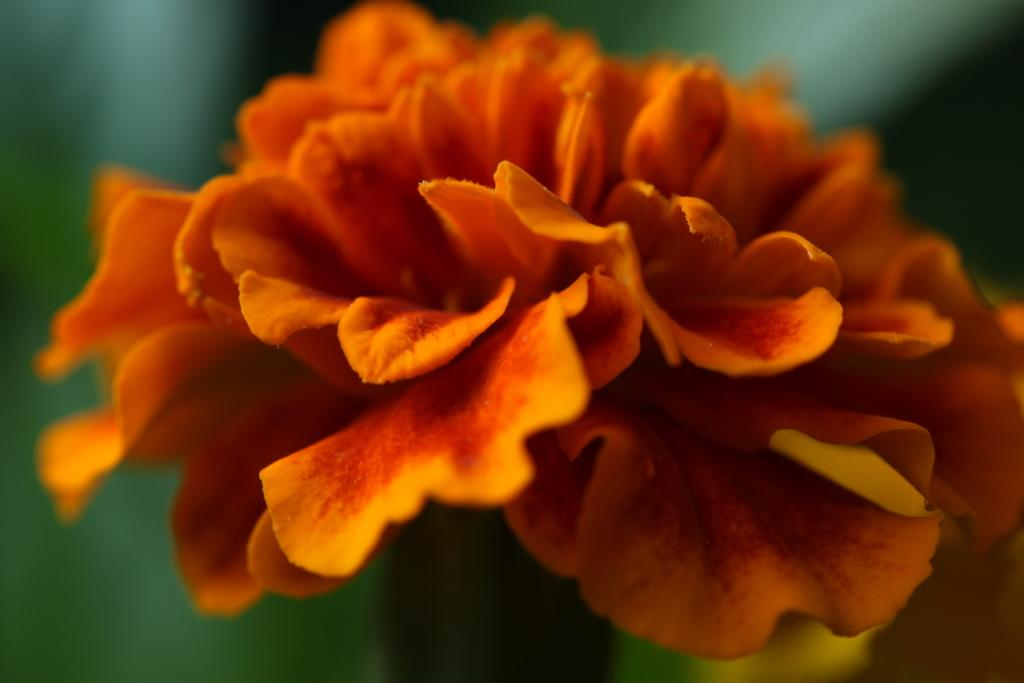What is the main subject of the image? There is a flower in the image. Can you describe the background of the image? The background of the image is blurry. What type of shade is being used to protect the flower from the sun in the image? There is no shade present in the image; it only features a flower and a blurry background. What type of material is the flower made of, such as brass or other metals? The flower is not made of brass or any other metal; it is a natural plant. 